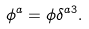Convert formula to latex. <formula><loc_0><loc_0><loc_500><loc_500>\phi ^ { a } = \phi \delta ^ { a 3 } .</formula> 